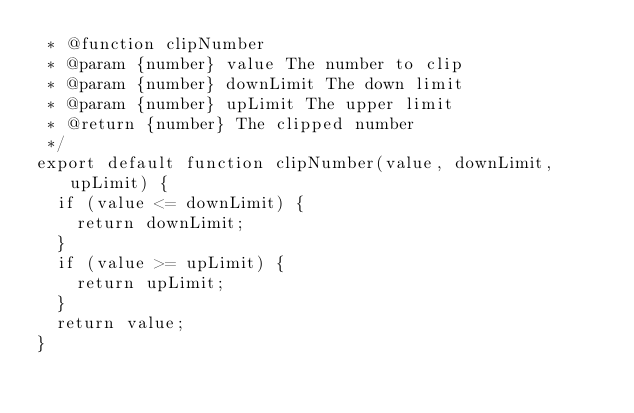Convert code to text. <code><loc_0><loc_0><loc_500><loc_500><_JavaScript_> * @function clipNumber
 * @param {number} value The number to clip
 * @param {number} downLimit The down limit
 * @param {number} upLimit The upper limit
 * @return {number} The clipped number
 */
export default function clipNumber(value, downLimit, upLimit) {
  if (value <= downLimit) {
    return downLimit;
  }
  if (value >= upLimit) {
    return upLimit;
  }
  return value;
}
</code> 